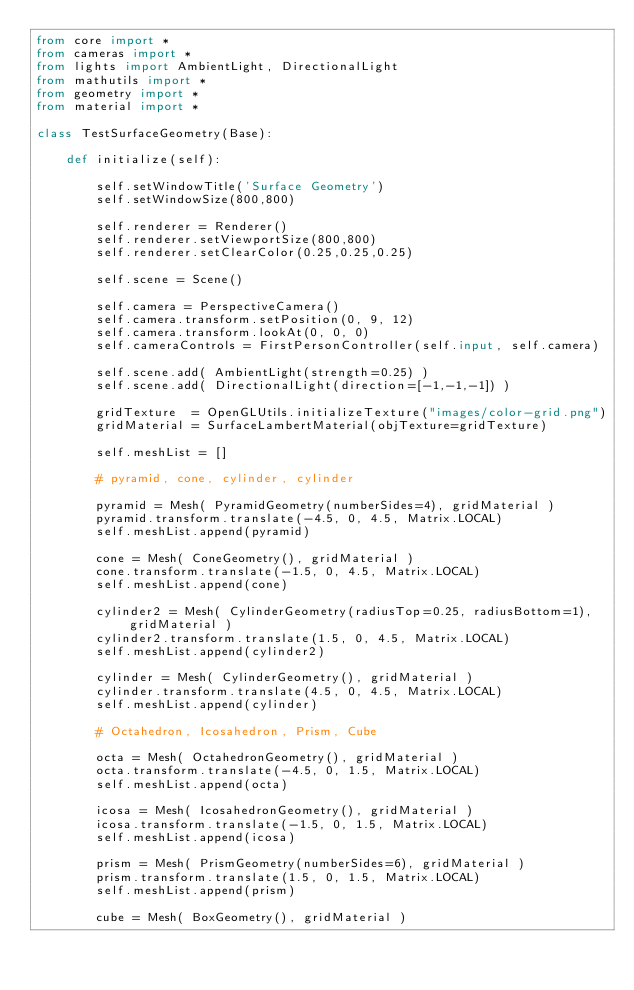Convert code to text. <code><loc_0><loc_0><loc_500><loc_500><_Python_>from core import *
from cameras import *
from lights import AmbientLight, DirectionalLight
from mathutils import *
from geometry import *
from material import *

class TestSurfaceGeometry(Base):
    
    def initialize(self):

        self.setWindowTitle('Surface Geometry')
        self.setWindowSize(800,800)

        self.renderer = Renderer()
        self.renderer.setViewportSize(800,800)
        self.renderer.setClearColor(0.25,0.25,0.25)
        
        self.scene = Scene()
        
        self.camera = PerspectiveCamera()
        self.camera.transform.setPosition(0, 9, 12)
        self.camera.transform.lookAt(0, 0, 0)
        self.cameraControls = FirstPersonController(self.input, self.camera)

        self.scene.add( AmbientLight(strength=0.25) )
        self.scene.add( DirectionalLight(direction=[-1,-1,-1]) )
        
        gridTexture  = OpenGLUtils.initializeTexture("images/color-grid.png")
        gridMaterial = SurfaceLambertMaterial(objTexture=gridTexture)

        self.meshList = []
        
        # pyramid, cone, cylinder, cylinder
        
        pyramid = Mesh( PyramidGeometry(numberSides=4), gridMaterial )
        pyramid.transform.translate(-4.5, 0, 4.5, Matrix.LOCAL)
        self.meshList.append(pyramid)

        cone = Mesh( ConeGeometry(), gridMaterial )
        cone.transform.translate(-1.5, 0, 4.5, Matrix.LOCAL)
        self.meshList.append(cone)

        cylinder2 = Mesh( CylinderGeometry(radiusTop=0.25, radiusBottom=1), gridMaterial )
        cylinder2.transform.translate(1.5, 0, 4.5, Matrix.LOCAL)
        self.meshList.append(cylinder2)

        cylinder = Mesh( CylinderGeometry(), gridMaterial )
        cylinder.transform.translate(4.5, 0, 4.5, Matrix.LOCAL)
        self.meshList.append(cylinder)
        
        # Octahedron, Icosahedron, Prism, Cube
        
        octa = Mesh( OctahedronGeometry(), gridMaterial )
        octa.transform.translate(-4.5, 0, 1.5, Matrix.LOCAL)
        self.meshList.append(octa)
        
        icosa = Mesh( IcosahedronGeometry(), gridMaterial )
        icosa.transform.translate(-1.5, 0, 1.5, Matrix.LOCAL)
        self.meshList.append(icosa)

        prism = Mesh( PrismGeometry(numberSides=6), gridMaterial )
        prism.transform.translate(1.5, 0, 1.5, Matrix.LOCAL)
        self.meshList.append(prism)

        cube = Mesh( BoxGeometry(), gridMaterial )</code> 